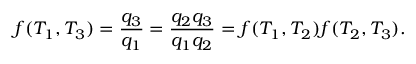Convert formula to latex. <formula><loc_0><loc_0><loc_500><loc_500>f ( T _ { 1 } , T _ { 3 } ) = { \frac { q _ { 3 } } { q _ { 1 } } } = { \frac { q _ { 2 } q _ { 3 } } { q _ { 1 } q _ { 2 } } } = f ( T _ { 1 } , T _ { 2 } ) f ( T _ { 2 } , T _ { 3 } ) .</formula> 